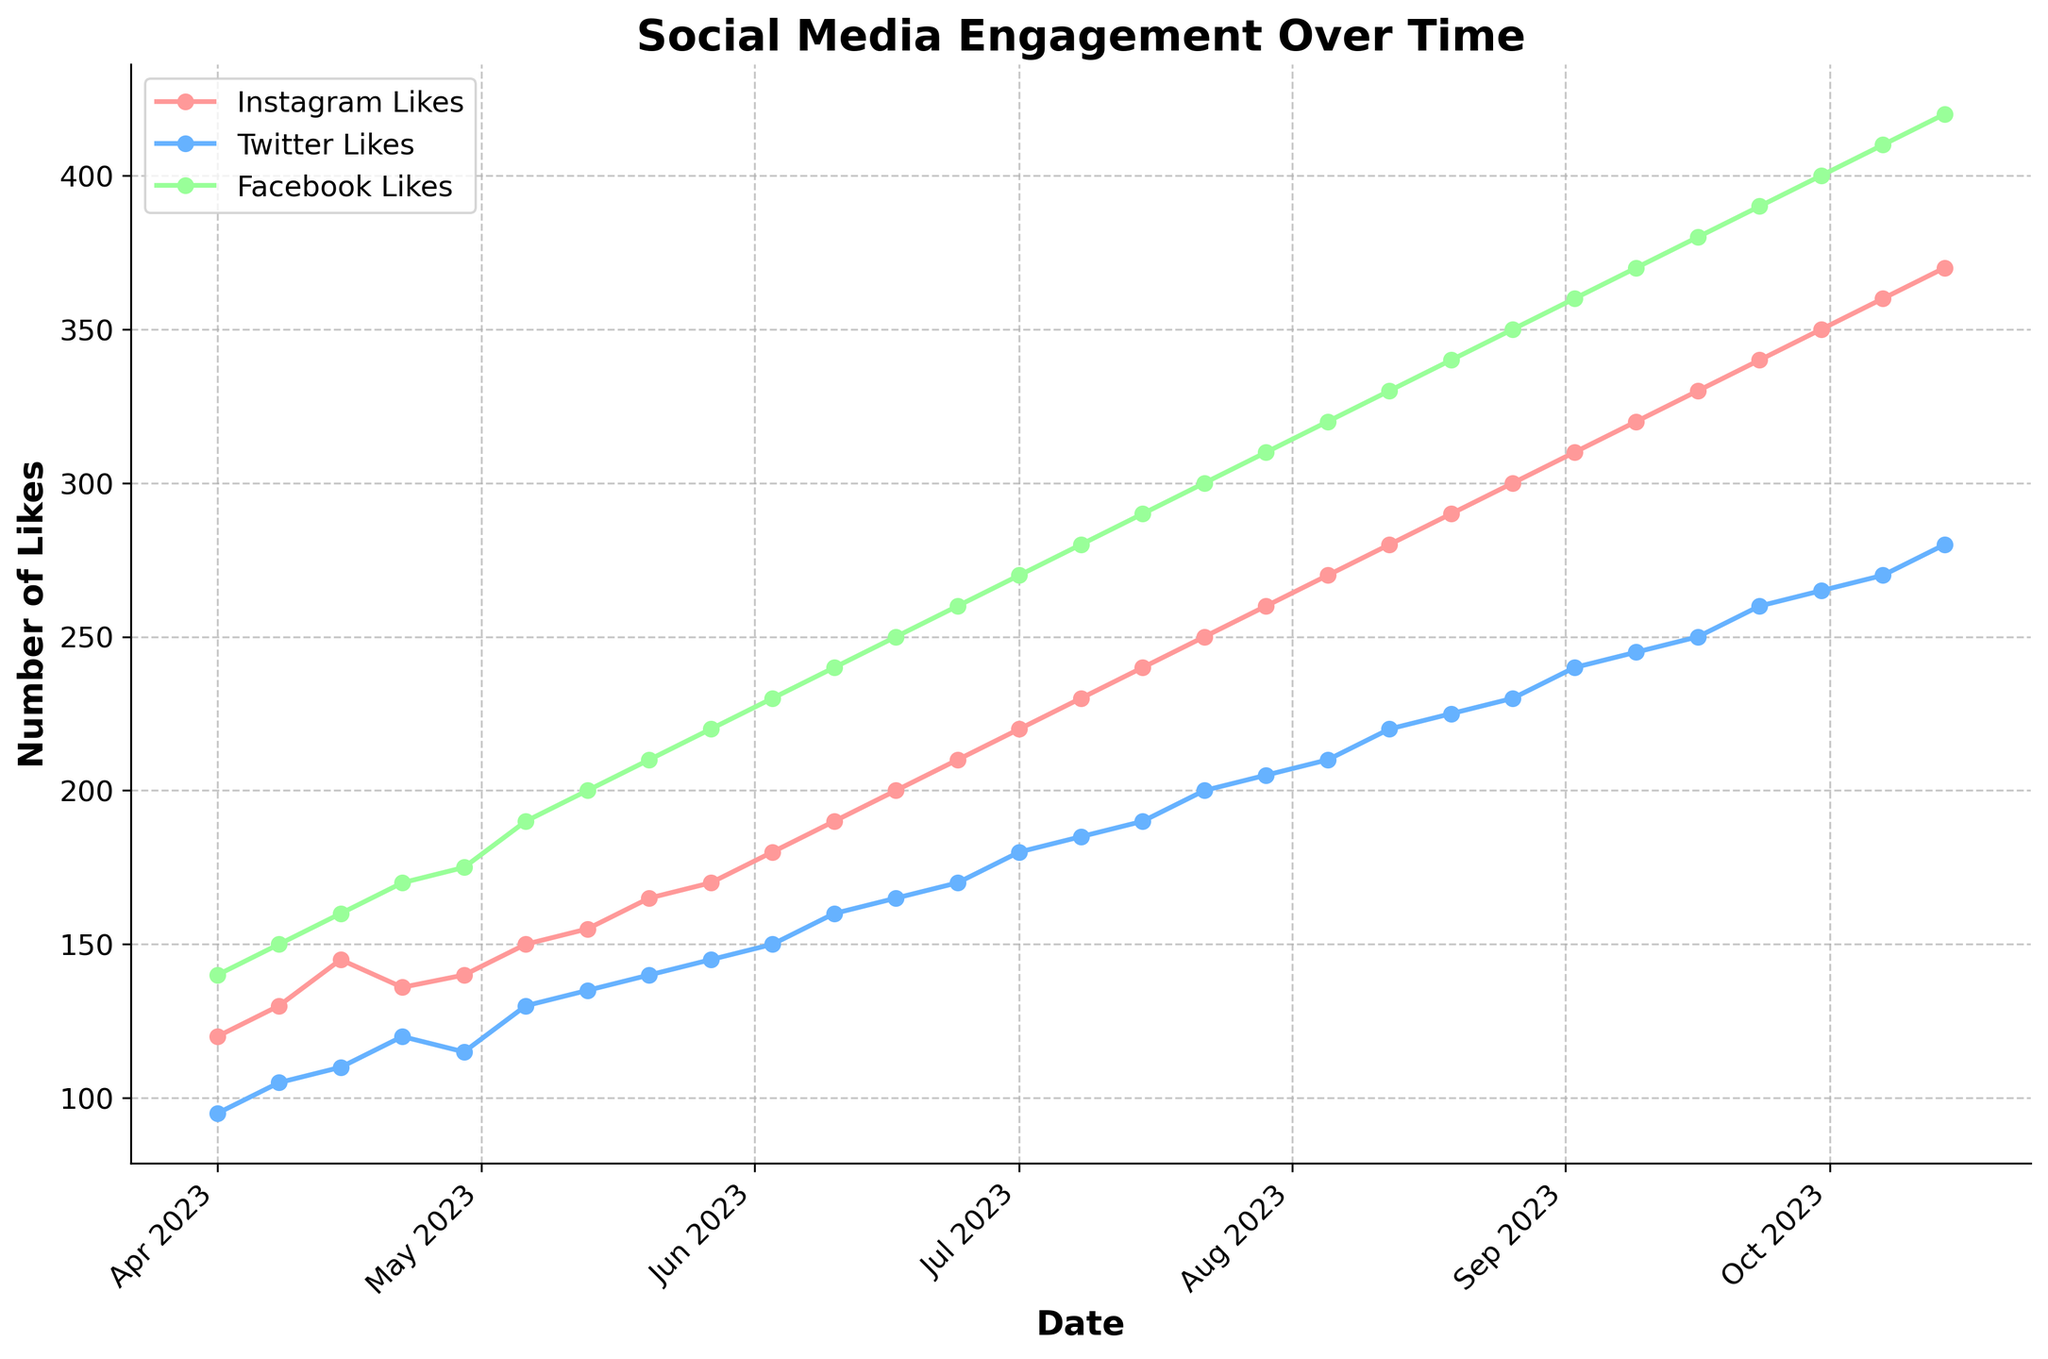What is the title of the figure? The title of the figure is typically located at the top center of the plot. You can look there to find it.
Answer: Social Media Engagement Over Time What are the three platforms shown in the figure? You can identify the platforms by looking at the legend on the plot, which lists the different lines and their corresponding labels.
Answer: Instagram, Twitter, Facebook Which platform had the highest number of likes on August 19, 2023? Look at the data points for August 19, 2023, on the x-axis and compare the heights of the lines corresponding to each platform.
Answer: Facebook What is the total number of likes for all platforms on September 30, 2023? Add the number of likes for Instagram, Twitter, and Facebook on September 30, 2023, from the y-axis values.
Answer: 1015 How did the number of Instagram likes change from April 1, 2023, to October 14, 2023? Subtract the number of Instagram likes on April 1, 2023, from the number of Instagram likes on October 14, 2023.
Answer: Increased by 250 Which month saw the most significant jump in Facebook likes? Look for the most substantial increase in the slope of the Facebook Likes line between two consecutive months.
Answer: August How many data points are plotted for each platform? Count the number of data points (or markers) for any one platform on the plot.
Answer: 28 On which exact date did Instagram likes first reach 200? Find the data point where the Instagram Likes line first touches or crosses the 200 mark on the y-axis, then trace it to the corresponding date on the x-axis.
Answer: June 17, 2023 When did Twitter likes begin to consistently exceed 200? Identify the date on the x-axis where the Twitter Likes line first stays above the 200 likes mark without dropping below it in subsequent data points.
Answer: August 19, 2023 Compare the Instagram and Twitter likes on July 15, 2023. Which platform had more engagement? Find the data points for both Instagram and Twitter on July 15, 2023, and compare their heights on the y-axis.
Answer: Instagram 